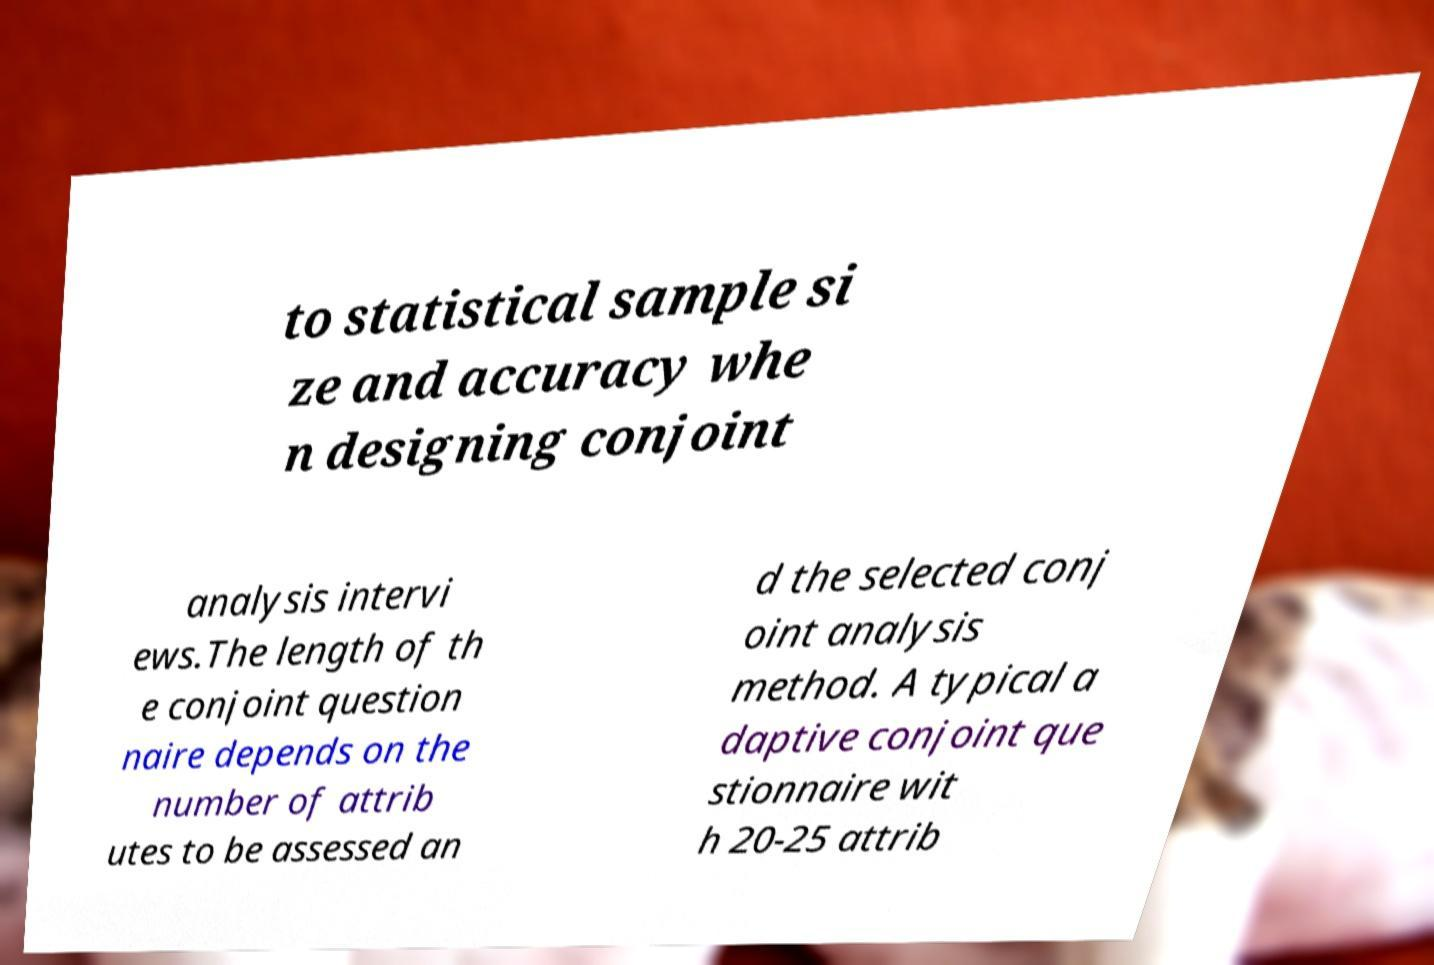Could you extract and type out the text from this image? to statistical sample si ze and accuracy whe n designing conjoint analysis intervi ews.The length of th e conjoint question naire depends on the number of attrib utes to be assessed an d the selected conj oint analysis method. A typical a daptive conjoint que stionnaire wit h 20-25 attrib 